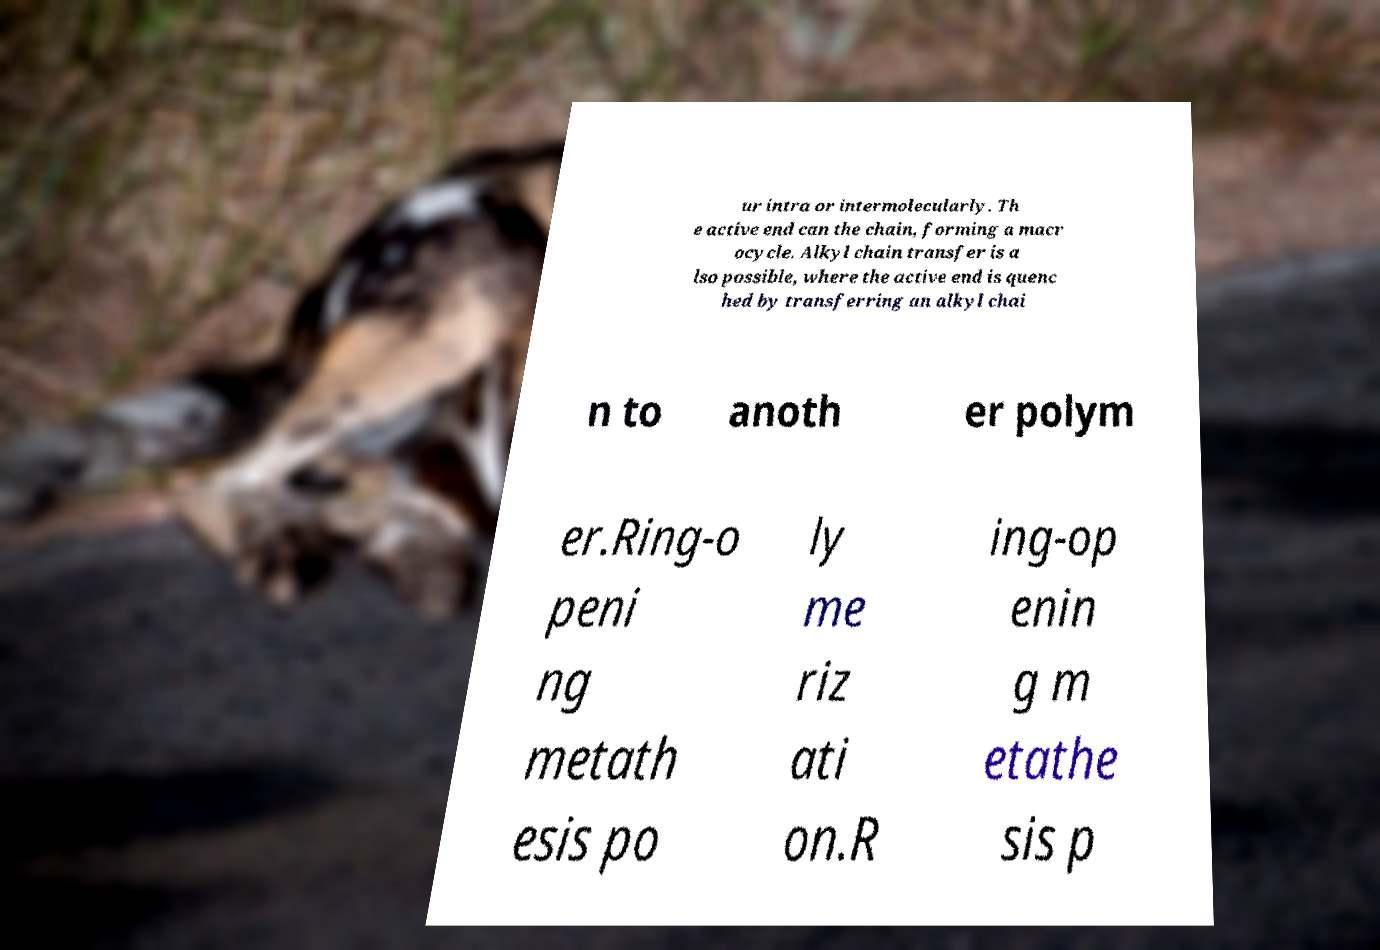Please identify and transcribe the text found in this image. ur intra or intermolecularly. Th e active end can the chain, forming a macr ocycle. Alkyl chain transfer is a lso possible, where the active end is quenc hed by transferring an alkyl chai n to anoth er polym er.Ring-o peni ng metath esis po ly me riz ati on.R ing-op enin g m etathe sis p 